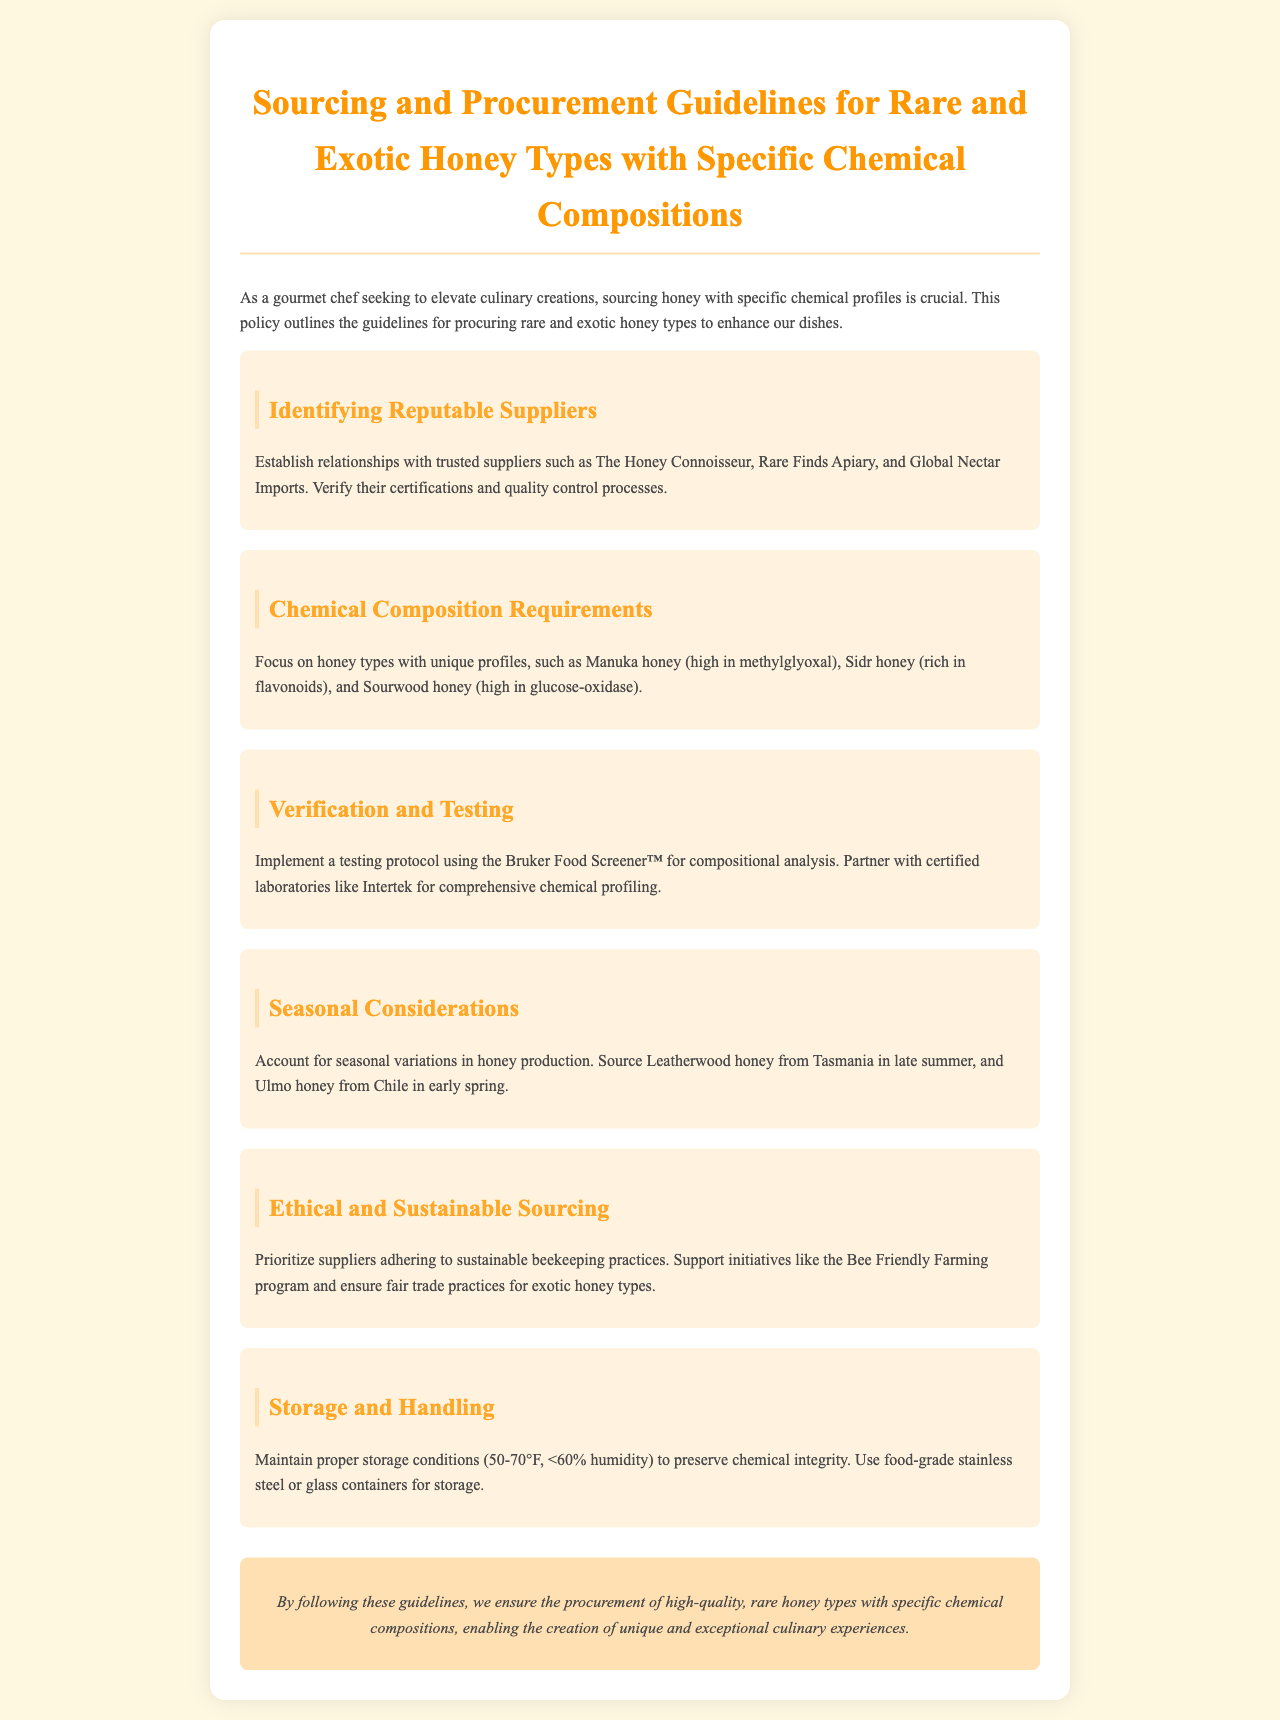What are the names of two reputable suppliers? The document specifies "The Honey Connoisseur" and "Rare Finds Apiary" as trusted suppliers.
Answer: The Honey Connoisseur, Rare Finds Apiary What chemical profile is Manuka honey high in? The document mentions that Manuka honey is high in "methylglyoxal."
Answer: methylglyoxal Which laboratory is suggested for chemical profiling? The document states that partnering with "Intertek" is recommended for comprehensive chemical profiling.
Answer: Intertek What is the temperature range for proper honey storage? The document specifies a temperature range of "50-70°F" for proper storage conditions.
Answer: 50-70°F Which honey is sourced from Tasmania in late summer? The document indicates that "Leatherwood honey" is sourced from Tasmania in late summer.
Answer: Leatherwood honey What initiative supports sustainable beekeeping practices? The document refers to the "Bee Friendly Farming program" as an initiative supporting sustainable practices.
Answer: Bee Friendly Farming program What is the humidity level specified for honey storage? The document states that humidity should be "<60%."
Answer: <60% Which honey type is rich in flavonoids? The document identifies "Sidr honey" as being rich in flavonoids.
Answer: Sidr honey What is the focus of this sourcing and procurement policy? The explanation specifies that the focus is on sourcing honey with "specific chemical profiles" for enhancing culinary creations.
Answer: specific chemical profiles 